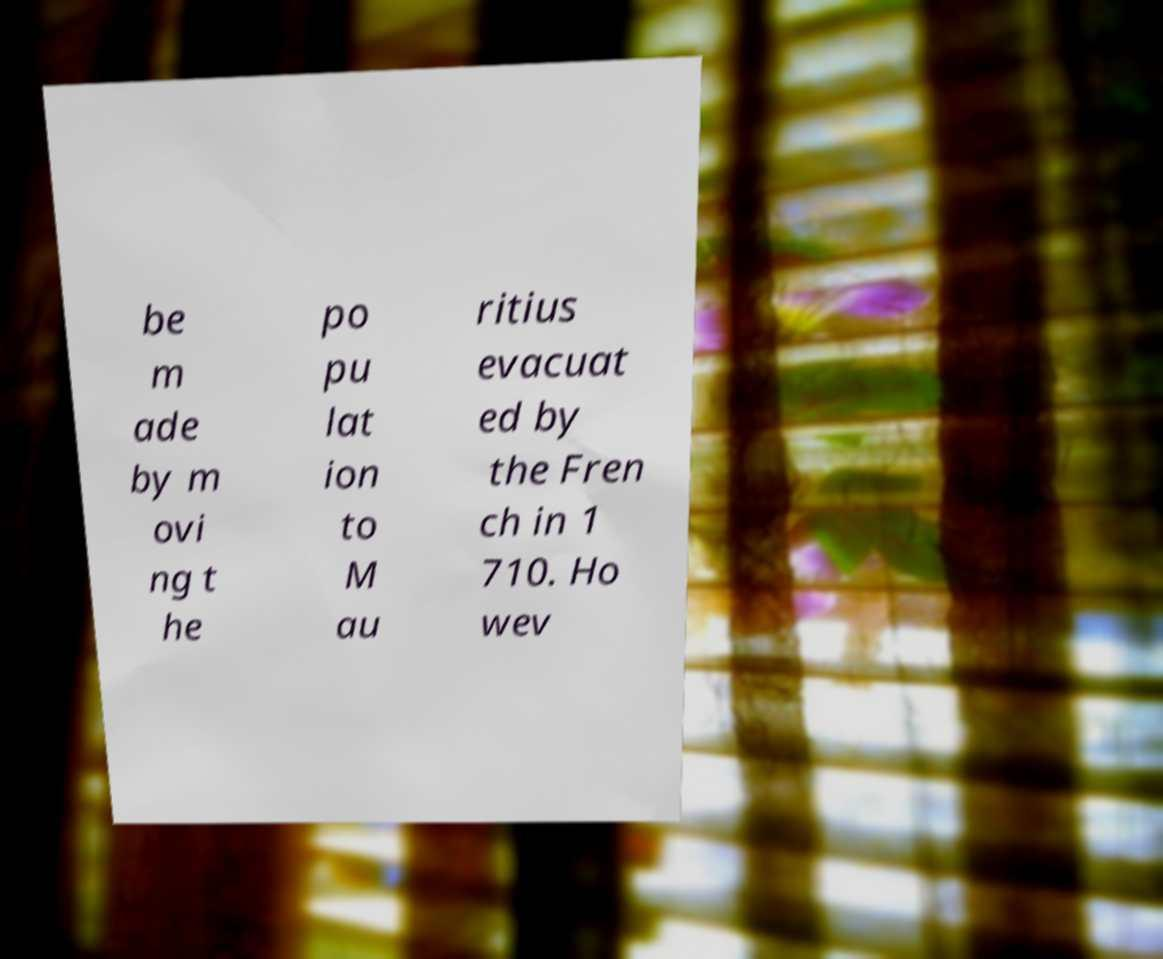Could you assist in decoding the text presented in this image and type it out clearly? be m ade by m ovi ng t he po pu lat ion to M au ritius evacuat ed by the Fren ch in 1 710. Ho wev 